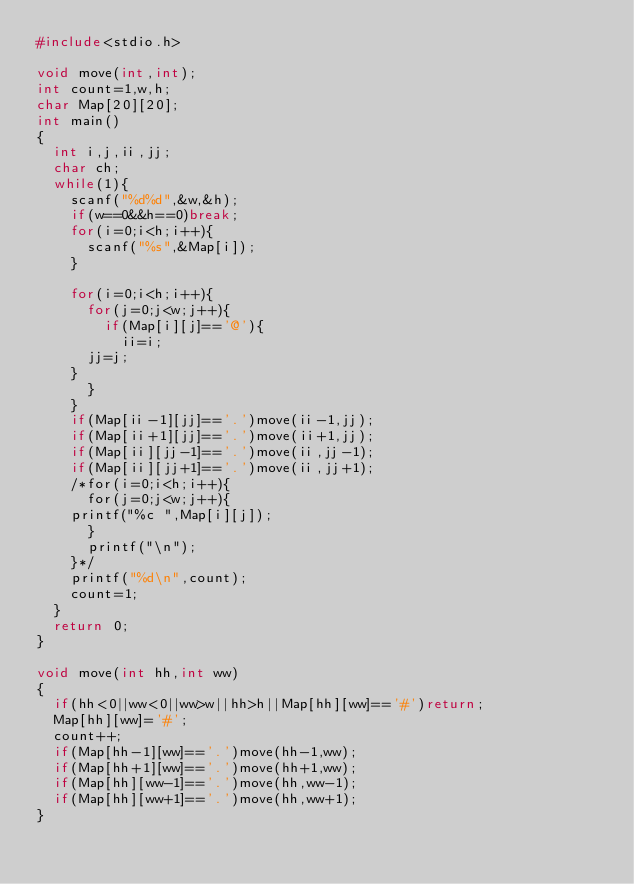Convert code to text. <code><loc_0><loc_0><loc_500><loc_500><_C_>#include<stdio.h>

void move(int,int);
int count=1,w,h;
char Map[20][20];
int main()
{
  int i,j,ii,jj;
  char ch;
  while(1){
    scanf("%d%d",&w,&h);
    if(w==0&&h==0)break;
    for(i=0;i<h;i++){
      scanf("%s",&Map[i]);
    }
    
    for(i=0;i<h;i++){
      for(j=0;j<w;j++){
        if(Map[i][j]=='@'){
          ii=i;
	  jj=j;
	}
      }
    }
    if(Map[ii-1][jj]=='.')move(ii-1,jj); 
    if(Map[ii+1][jj]=='.')move(ii+1,jj);
    if(Map[ii][jj-1]=='.')move(ii,jj-1); 
    if(Map[ii][jj+1]=='.')move(ii,jj+1);
    /*for(i=0;i<h;i++){
      for(j=0;j<w;j++){
	printf("%c ",Map[i][j]);
      }
      printf("\n");
    }*/
    printf("%d\n",count);
    count=1;
  }
  return 0;
}

void move(int hh,int ww)
{
  if(hh<0||ww<0||ww>w||hh>h||Map[hh][ww]=='#')return;
  Map[hh][ww]='#';
  count++;
  if(Map[hh-1][ww]=='.')move(hh-1,ww); 
  if(Map[hh+1][ww]=='.')move(hh+1,ww);
  if(Map[hh][ww-1]=='.')move(hh,ww-1); 
  if(Map[hh][ww+1]=='.')move(hh,ww+1);
}</code> 